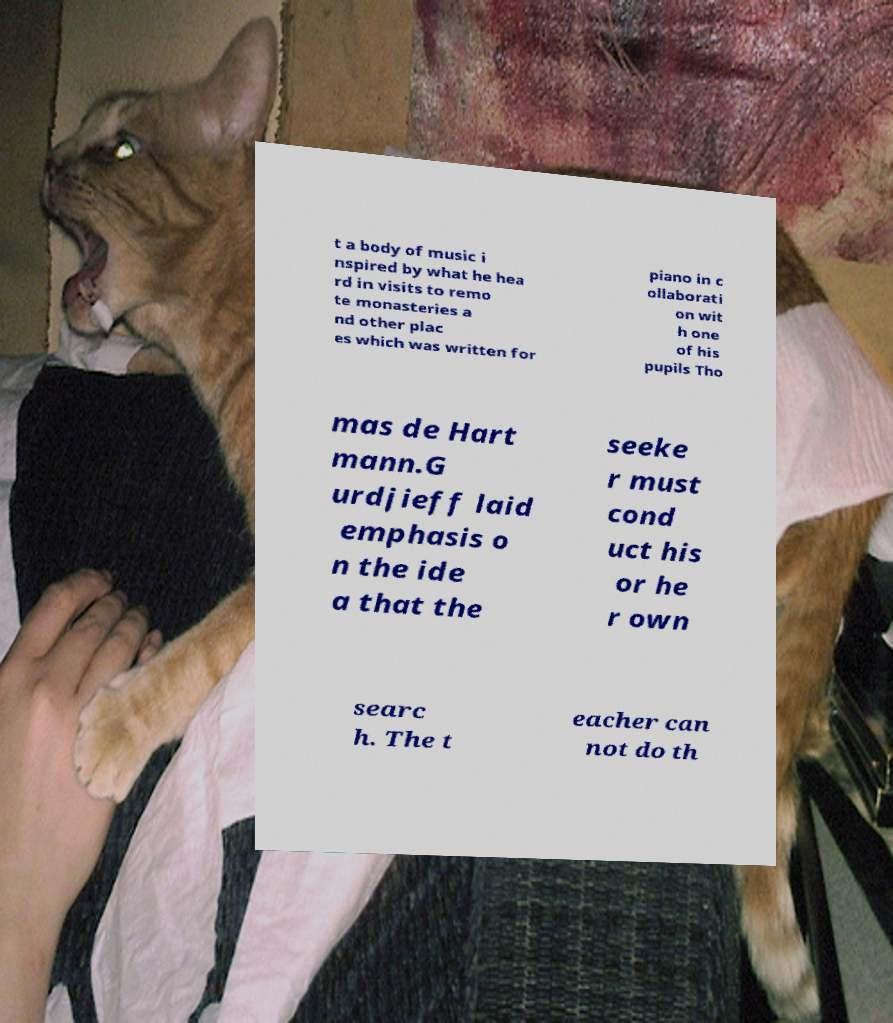What messages or text are displayed in this image? I need them in a readable, typed format. t a body of music i nspired by what he hea rd in visits to remo te monasteries a nd other plac es which was written for piano in c ollaborati on wit h one of his pupils Tho mas de Hart mann.G urdjieff laid emphasis o n the ide a that the seeke r must cond uct his or he r own searc h. The t eacher can not do th 